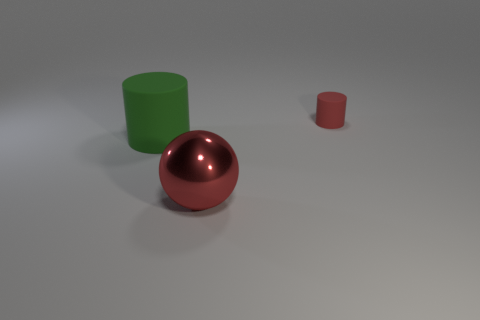What number of cylinders are small matte things or big green objects?
Ensure brevity in your answer.  2. What color is the object that is in front of the big rubber thing?
Make the answer very short. Red. What is the shape of the large metallic object that is the same color as the tiny matte cylinder?
Keep it short and to the point. Sphere. What number of green metal cylinders are the same size as the sphere?
Offer a very short reply. 0. There is a red object in front of the big matte object; is its shape the same as the tiny red object right of the big matte cylinder?
Offer a terse response. No. What is the material of the object that is behind the matte object on the left side of the thing that is behind the big cylinder?
Your response must be concise. Rubber. The green object that is the same size as the red ball is what shape?
Your response must be concise. Cylinder. Is there another matte thing that has the same color as the large rubber thing?
Your answer should be very brief. No. The green cylinder has what size?
Your answer should be compact. Large. Is the material of the green cylinder the same as the large ball?
Offer a very short reply. No. 